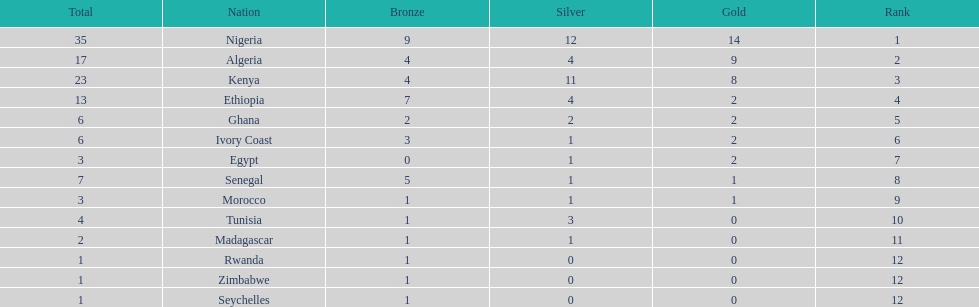Which team has the highest number of gold medals? Nigeria. 